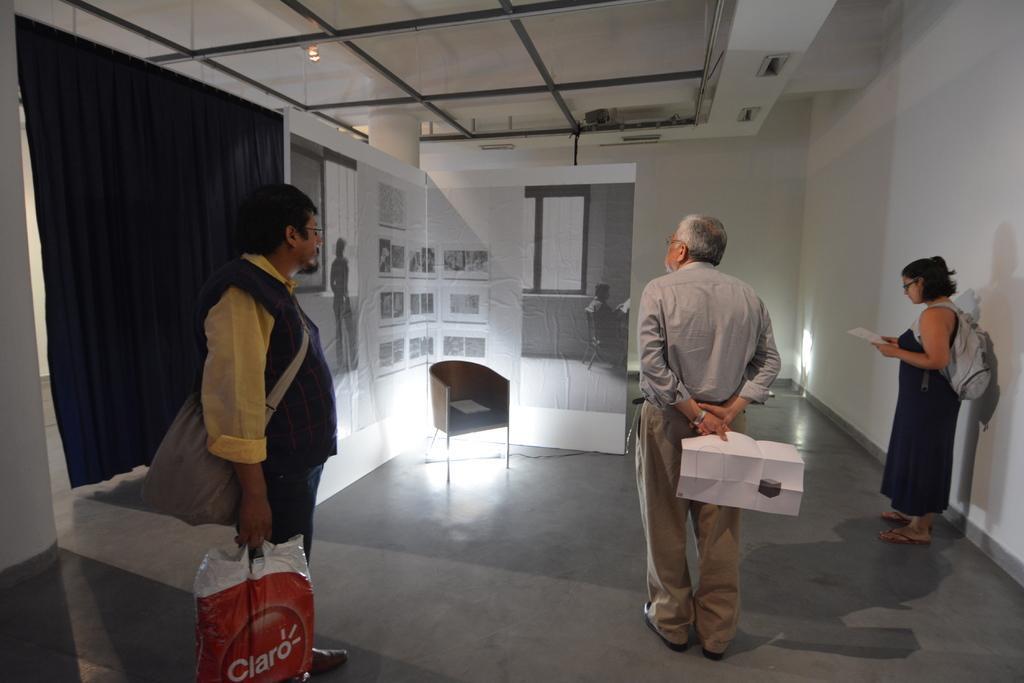Could you give a brief overview of what you see in this image? In this image we can see two men and a woman standing on the floor. In that a man and a woman are holding some papers and the other is holding a cover. On the backside we can see a curtain, a board with a black and white picture on it, a chair with an object placed on it, a wall and a roof with some metal rods and a ceiling light. 